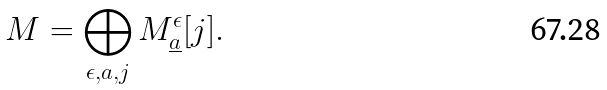Convert formula to latex. <formula><loc_0><loc_0><loc_500><loc_500>M = \bigoplus _ { \epsilon , a , j } M ^ { \epsilon } _ { \underline { a } } [ j ] .</formula> 